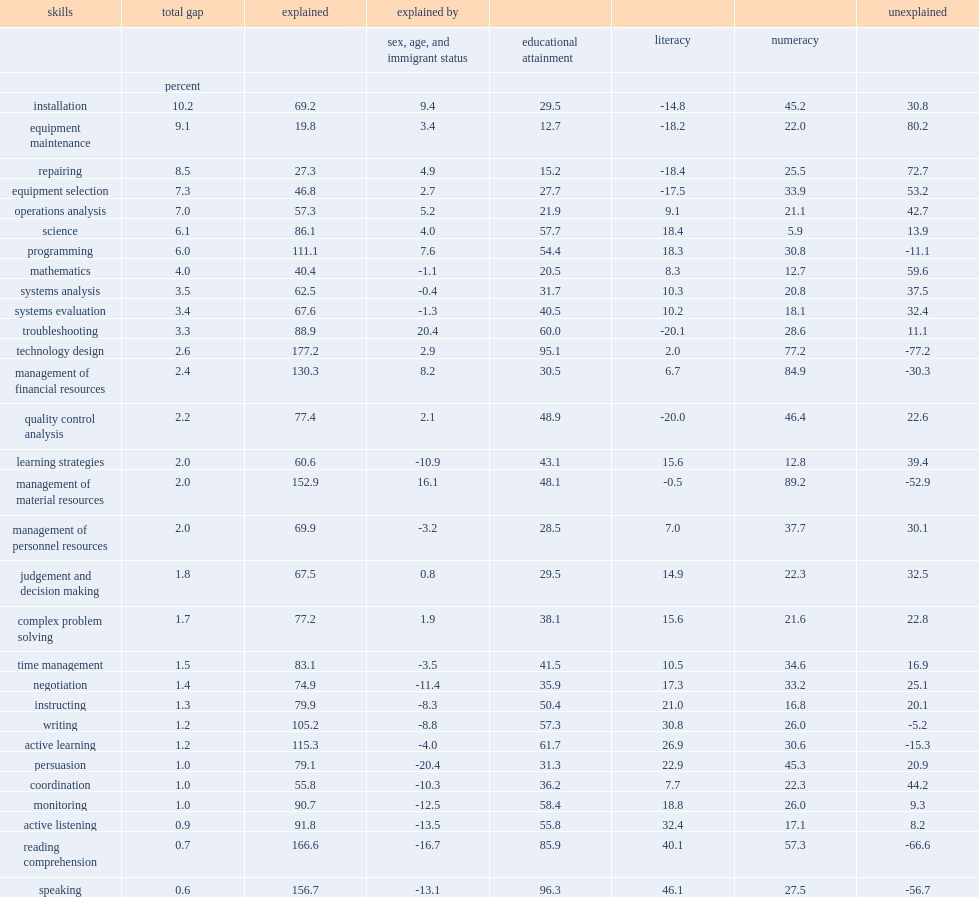How many percent does numeracy account for the gap in management of personnel resources? 37.7. How many percent do literacy skills account for the gap in management of personnel resources? 7.0. 